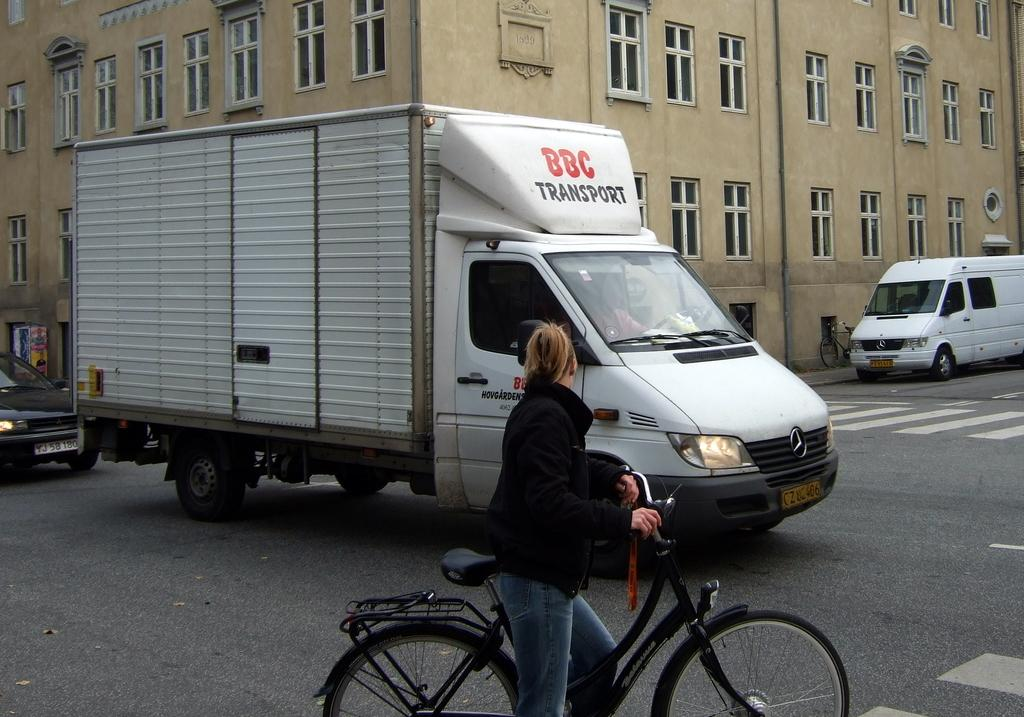<image>
Offer a succinct explanation of the picture presented. A woman on a bike staring at a white van labeled BBC Transportation. 